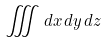<formula> <loc_0><loc_0><loc_500><loc_500>\iiint d x \, d y \, d z</formula> 